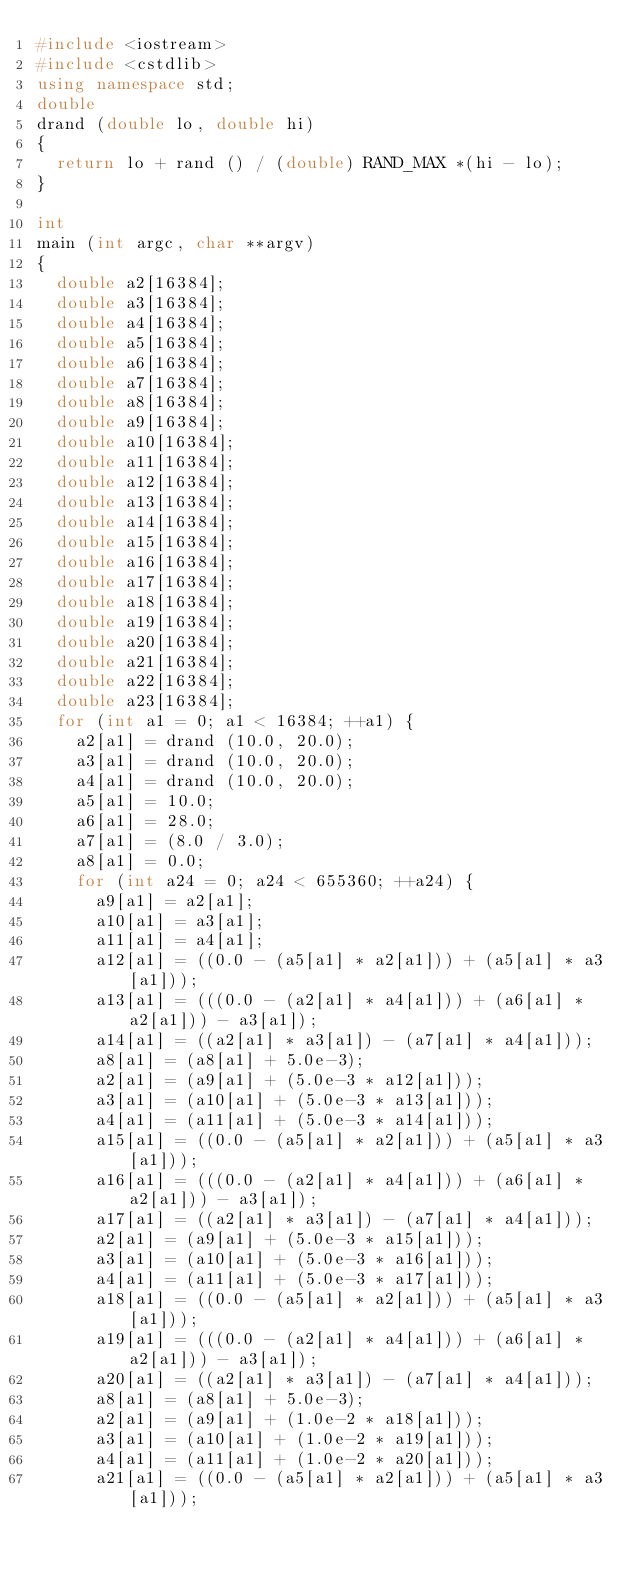Convert code to text. <code><loc_0><loc_0><loc_500><loc_500><_C++_>#include <iostream>
#include <cstdlib>
using namespace std;
double
drand (double lo, double hi)
{
  return lo + rand () / (double) RAND_MAX *(hi - lo);
}

int
main (int argc, char **argv)
{
  double a2[16384];
  double a3[16384];
  double a4[16384];
  double a5[16384];
  double a6[16384];
  double a7[16384];
  double a8[16384];
  double a9[16384];
  double a10[16384];
  double a11[16384];
  double a12[16384];
  double a13[16384];
  double a14[16384];
  double a15[16384];
  double a16[16384];
  double a17[16384];
  double a18[16384];
  double a19[16384];
  double a20[16384];
  double a21[16384];
  double a22[16384];
  double a23[16384];
  for (int a1 = 0; a1 < 16384; ++a1) {
    a2[a1] = drand (10.0, 20.0);
    a3[a1] = drand (10.0, 20.0);
    a4[a1] = drand (10.0, 20.0);
    a5[a1] = 10.0;
    a6[a1] = 28.0;
    a7[a1] = (8.0 / 3.0);
    a8[a1] = 0.0;
    for (int a24 = 0; a24 < 655360; ++a24) {
      a9[a1] = a2[a1];
      a10[a1] = a3[a1];
      a11[a1] = a4[a1];
      a12[a1] = ((0.0 - (a5[a1] * a2[a1])) + (a5[a1] * a3[a1]));
      a13[a1] = (((0.0 - (a2[a1] * a4[a1])) + (a6[a1] * a2[a1])) - a3[a1]);
      a14[a1] = ((a2[a1] * a3[a1]) - (a7[a1] * a4[a1]));
      a8[a1] = (a8[a1] + 5.0e-3);
      a2[a1] = (a9[a1] + (5.0e-3 * a12[a1]));
      a3[a1] = (a10[a1] + (5.0e-3 * a13[a1]));
      a4[a1] = (a11[a1] + (5.0e-3 * a14[a1]));
      a15[a1] = ((0.0 - (a5[a1] * a2[a1])) + (a5[a1] * a3[a1]));
      a16[a1] = (((0.0 - (a2[a1] * a4[a1])) + (a6[a1] * a2[a1])) - a3[a1]);
      a17[a1] = ((a2[a1] * a3[a1]) - (a7[a1] * a4[a1]));
      a2[a1] = (a9[a1] + (5.0e-3 * a15[a1]));
      a3[a1] = (a10[a1] + (5.0e-3 * a16[a1]));
      a4[a1] = (a11[a1] + (5.0e-3 * a17[a1]));
      a18[a1] = ((0.0 - (a5[a1] * a2[a1])) + (a5[a1] * a3[a1]));
      a19[a1] = (((0.0 - (a2[a1] * a4[a1])) + (a6[a1] * a2[a1])) - a3[a1]);
      a20[a1] = ((a2[a1] * a3[a1]) - (a7[a1] * a4[a1]));
      a8[a1] = (a8[a1] + 5.0e-3);
      a2[a1] = (a9[a1] + (1.0e-2 * a18[a1]));
      a3[a1] = (a10[a1] + (1.0e-2 * a19[a1]));
      a4[a1] = (a11[a1] + (1.0e-2 * a20[a1]));
      a21[a1] = ((0.0 - (a5[a1] * a2[a1])) + (a5[a1] * a3[a1]));</code> 